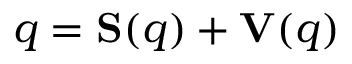Convert formula to latex. <formula><loc_0><loc_0><loc_500><loc_500>q = S ( q ) + V ( q )</formula> 